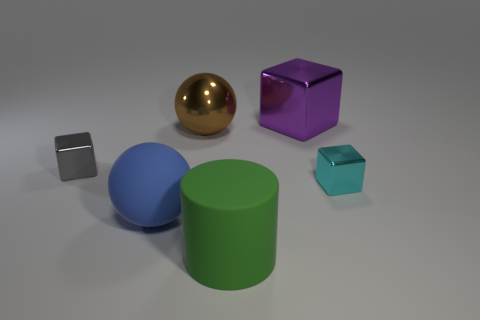There is a brown sphere; does it have the same size as the sphere in front of the cyan shiny cube?
Your response must be concise. Yes. How many objects are either large things to the right of the large brown thing or big balls left of the cyan metallic object?
Provide a succinct answer. 4. What is the shape of the brown metal object that is the same size as the blue sphere?
Give a very brief answer. Sphere. There is a small shiny object behind the metal block that is to the right of the purple object right of the brown sphere; what is its shape?
Your answer should be compact. Cube. Is the number of matte balls behind the cyan metal object the same as the number of tiny cyan blocks?
Your answer should be very brief. No. Is the blue sphere the same size as the cylinder?
Your answer should be compact. Yes. How many rubber things are big gray cylinders or small gray objects?
Provide a succinct answer. 0. There is a cylinder that is the same size as the blue object; what is its material?
Provide a succinct answer. Rubber. How many other objects are there of the same material as the large green thing?
Make the answer very short. 1. Is the number of gray metallic blocks that are in front of the cyan object less than the number of brown balls?
Give a very brief answer. Yes. 